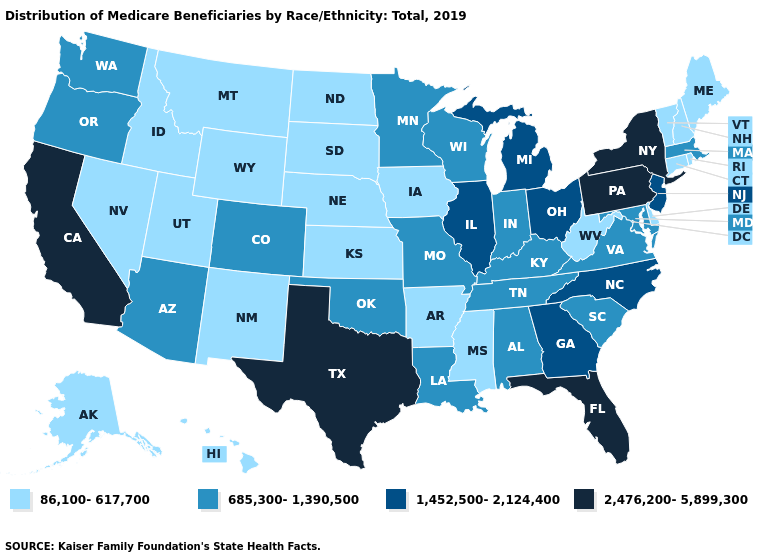Name the states that have a value in the range 86,100-617,700?
Write a very short answer. Alaska, Arkansas, Connecticut, Delaware, Hawaii, Idaho, Iowa, Kansas, Maine, Mississippi, Montana, Nebraska, Nevada, New Hampshire, New Mexico, North Dakota, Rhode Island, South Dakota, Utah, Vermont, West Virginia, Wyoming. Name the states that have a value in the range 2,476,200-5,899,300?
Short answer required. California, Florida, New York, Pennsylvania, Texas. Name the states that have a value in the range 1,452,500-2,124,400?
Short answer required. Georgia, Illinois, Michigan, New Jersey, North Carolina, Ohio. What is the value of New Hampshire?
Give a very brief answer. 86,100-617,700. What is the value of Iowa?
Keep it brief. 86,100-617,700. What is the value of Florida?
Be succinct. 2,476,200-5,899,300. What is the value of Arizona?
Quick response, please. 685,300-1,390,500. Name the states that have a value in the range 86,100-617,700?
Be succinct. Alaska, Arkansas, Connecticut, Delaware, Hawaii, Idaho, Iowa, Kansas, Maine, Mississippi, Montana, Nebraska, Nevada, New Hampshire, New Mexico, North Dakota, Rhode Island, South Dakota, Utah, Vermont, West Virginia, Wyoming. Does the first symbol in the legend represent the smallest category?
Keep it brief. Yes. What is the value of Oklahoma?
Keep it brief. 685,300-1,390,500. Name the states that have a value in the range 86,100-617,700?
Write a very short answer. Alaska, Arkansas, Connecticut, Delaware, Hawaii, Idaho, Iowa, Kansas, Maine, Mississippi, Montana, Nebraska, Nevada, New Hampshire, New Mexico, North Dakota, Rhode Island, South Dakota, Utah, Vermont, West Virginia, Wyoming. Does Illinois have the highest value in the USA?
Answer briefly. No. What is the lowest value in the South?
Be succinct. 86,100-617,700. What is the value of Illinois?
Be succinct. 1,452,500-2,124,400. Does the first symbol in the legend represent the smallest category?
Write a very short answer. Yes. 